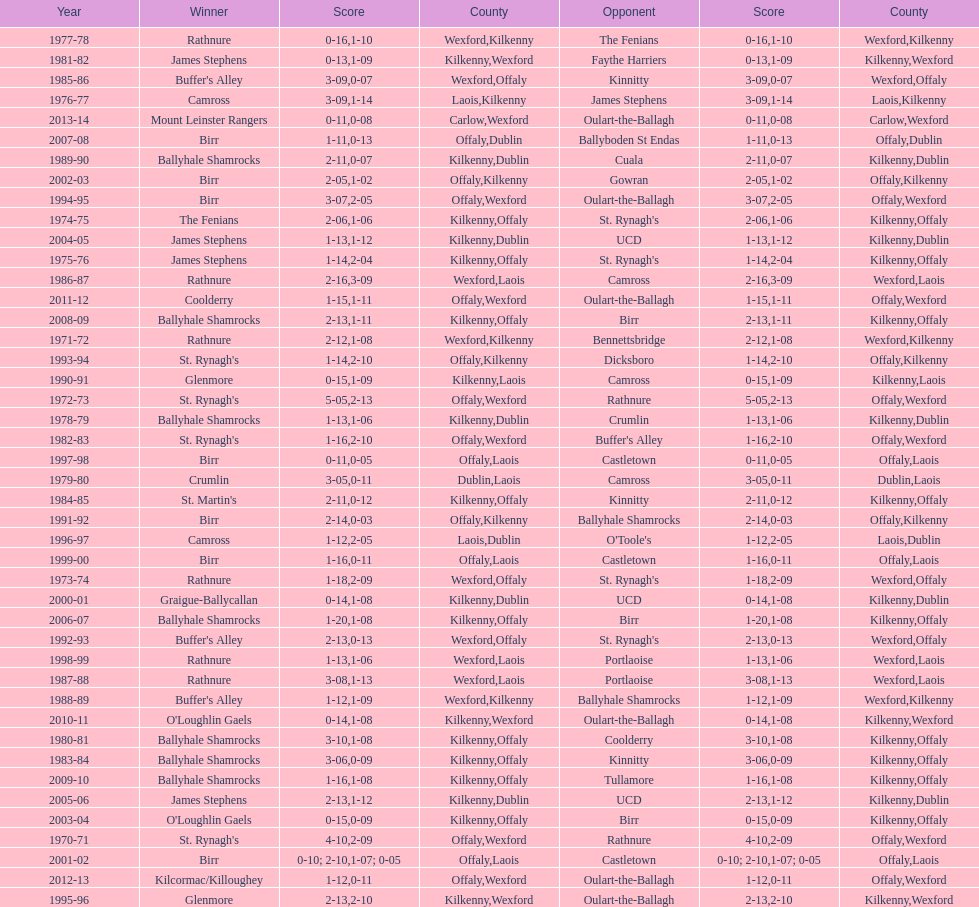I'm looking to parse the entire table for insights. Could you assist me with that? {'header': ['Year', 'Winner', 'Score', 'County', 'Opponent', 'Score', 'County'], 'rows': [['1977-78', 'Rathnure', '0-16', 'Wexford', 'The Fenians', '1-10', 'Kilkenny'], ['1981-82', 'James Stephens', '0-13', 'Kilkenny', 'Faythe Harriers', '1-09', 'Wexford'], ['1985-86', "Buffer's Alley", '3-09', 'Wexford', 'Kinnitty', '0-07', 'Offaly'], ['1976-77', 'Camross', '3-09', 'Laois', 'James Stephens', '1-14', 'Kilkenny'], ['2013-14', 'Mount Leinster Rangers', '0-11', 'Carlow', 'Oulart-the-Ballagh', '0-08', 'Wexford'], ['2007-08', 'Birr', '1-11', 'Offaly', 'Ballyboden St Endas', '0-13', 'Dublin'], ['1989-90', 'Ballyhale Shamrocks', '2-11', 'Kilkenny', 'Cuala', '0-07', 'Dublin'], ['2002-03', 'Birr', '2-05', 'Offaly', 'Gowran', '1-02', 'Kilkenny'], ['1994-95', 'Birr', '3-07', 'Offaly', 'Oulart-the-Ballagh', '2-05', 'Wexford'], ['1974-75', 'The Fenians', '2-06', 'Kilkenny', "St. Rynagh's", '1-06', 'Offaly'], ['2004-05', 'James Stephens', '1-13', 'Kilkenny', 'UCD', '1-12', 'Dublin'], ['1975-76', 'James Stephens', '1-14', 'Kilkenny', "St. Rynagh's", '2-04', 'Offaly'], ['1986-87', 'Rathnure', '2-16', 'Wexford', 'Camross', '3-09', 'Laois'], ['2011-12', 'Coolderry', '1-15', 'Offaly', 'Oulart-the-Ballagh', '1-11', 'Wexford'], ['2008-09', 'Ballyhale Shamrocks', '2-13', 'Kilkenny', 'Birr', '1-11', 'Offaly'], ['1971-72', 'Rathnure', '2-12', 'Wexford', 'Bennettsbridge', '1-08', 'Kilkenny'], ['1993-94', "St. Rynagh's", '1-14', 'Offaly', 'Dicksboro', '2-10', 'Kilkenny'], ['1990-91', 'Glenmore', '0-15', 'Kilkenny', 'Camross', '1-09', 'Laois'], ['1972-73', "St. Rynagh's", '5-05', 'Offaly', 'Rathnure', '2-13', 'Wexford'], ['1978-79', 'Ballyhale Shamrocks', '1-13', 'Kilkenny', 'Crumlin', '1-06', 'Dublin'], ['1982-83', "St. Rynagh's", '1-16', 'Offaly', "Buffer's Alley", '2-10', 'Wexford'], ['1997-98', 'Birr', '0-11', 'Offaly', 'Castletown', '0-05', 'Laois'], ['1979-80', 'Crumlin', '3-05', 'Dublin', 'Camross', '0-11', 'Laois'], ['1984-85', "St. Martin's", '2-11', 'Kilkenny', 'Kinnitty', '0-12', 'Offaly'], ['1991-92', 'Birr', '2-14', 'Offaly', 'Ballyhale Shamrocks', '0-03', 'Kilkenny'], ['1996-97', 'Camross', '1-12', 'Laois', "O'Toole's", '2-05', 'Dublin'], ['1999-00', 'Birr', '1-16', 'Offaly', 'Castletown', '0-11', 'Laois'], ['1973-74', 'Rathnure', '1-18', 'Wexford', "St. Rynagh's", '2-09', 'Offaly'], ['2000-01', 'Graigue-Ballycallan', '0-14', 'Kilkenny', 'UCD', '1-08', 'Dublin'], ['2006-07', 'Ballyhale Shamrocks', '1-20', 'Kilkenny', 'Birr', '1-08', 'Offaly'], ['1992-93', "Buffer's Alley", '2-13', 'Wexford', "St. Rynagh's", '0-13', 'Offaly'], ['1998-99', 'Rathnure', '1-13', 'Wexford', 'Portlaoise', '1-06', 'Laois'], ['1987-88', 'Rathnure', '3-08', 'Wexford', 'Portlaoise', '1-13', 'Laois'], ['1988-89', "Buffer's Alley", '1-12', 'Wexford', 'Ballyhale Shamrocks', '1-09', 'Kilkenny'], ['2010-11', "O'Loughlin Gaels", '0-14', 'Kilkenny', 'Oulart-the-Ballagh', '1-08', 'Wexford'], ['1980-81', 'Ballyhale Shamrocks', '3-10', 'Kilkenny', 'Coolderry', '1-08', 'Offaly'], ['1983-84', 'Ballyhale Shamrocks', '3-06', 'Kilkenny', 'Kinnitty', '0-09', 'Offaly'], ['2009-10', 'Ballyhale Shamrocks', '1-16', 'Kilkenny', 'Tullamore', '1-08', 'Offaly'], ['2005-06', 'James Stephens', '2-13', 'Kilkenny', 'UCD', '1-12', 'Dublin'], ['2003-04', "O'Loughlin Gaels", '0-15', 'Kilkenny', 'Birr', '0-09', 'Offaly'], ['1970-71', "St. Rynagh's", '4-10', 'Offaly', 'Rathnure', '2-09', 'Wexford'], ['2001-02', 'Birr', '0-10; 2-10', 'Offaly', 'Castletown', '1-07; 0-05', 'Laois'], ['2012-13', 'Kilcormac/Killoughey', '1-12', 'Offaly', 'Oulart-the-Ballagh', '0-11', 'Wexford'], ['1995-96', 'Glenmore', '2-13', 'Kilkenny', 'Oulart-the-Ballagh', '2-10', 'Wexford']]} Which country had the most wins? Kilkenny. 